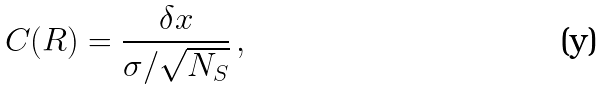<formula> <loc_0><loc_0><loc_500><loc_500>C ( R ) = \frac { \delta x } { \sigma / \sqrt { N _ { S } } } \, ,</formula> 